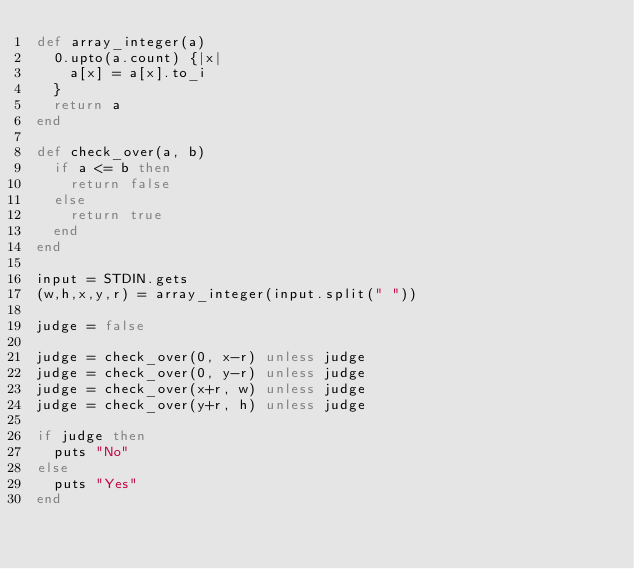<code> <loc_0><loc_0><loc_500><loc_500><_Ruby_>def array_integer(a)
	0.upto(a.count) {|x|
		a[x] = a[x].to_i
	}
	return a
end

def check_over(a, b)
	if a <= b then
		return false
	else
		return true
	end
end

input = STDIN.gets
(w,h,x,y,r) = array_integer(input.split(" "))

judge = false

judge = check_over(0, x-r) unless judge
judge = check_over(0, y-r) unless judge
judge = check_over(x+r, w) unless judge
judge = check_over(y+r, h) unless judge

if judge then
	puts "No"
else
	puts "Yes"
end

</code> 